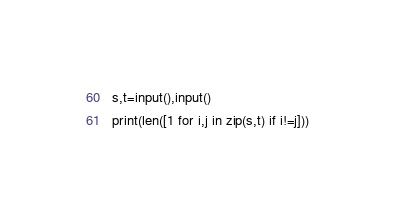<code> <loc_0><loc_0><loc_500><loc_500><_Python_>s,t=input(),input()
print(len([1 for i,j in zip(s,t) if i!=j]))</code> 